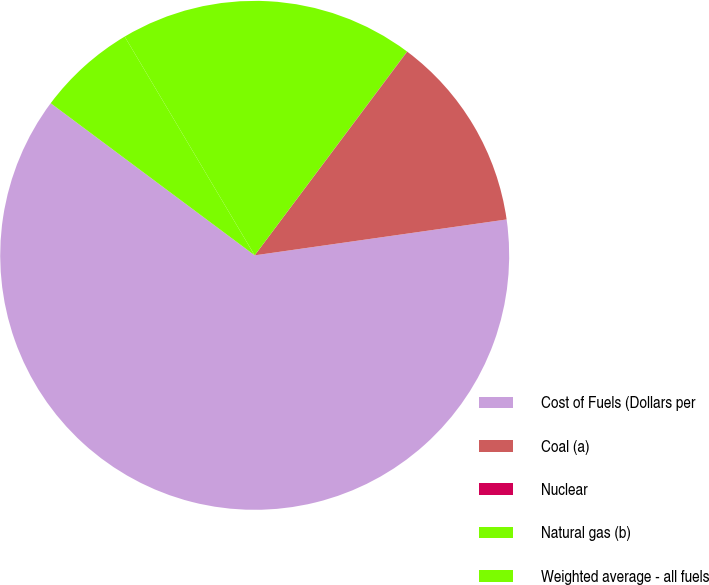Convert chart. <chart><loc_0><loc_0><loc_500><loc_500><pie_chart><fcel>Cost of Fuels (Dollars per<fcel>Coal (a)<fcel>Nuclear<fcel>Natural gas (b)<fcel>Weighted average - all fuels<nl><fcel>62.45%<fcel>12.51%<fcel>0.02%<fcel>18.75%<fcel>6.27%<nl></chart> 